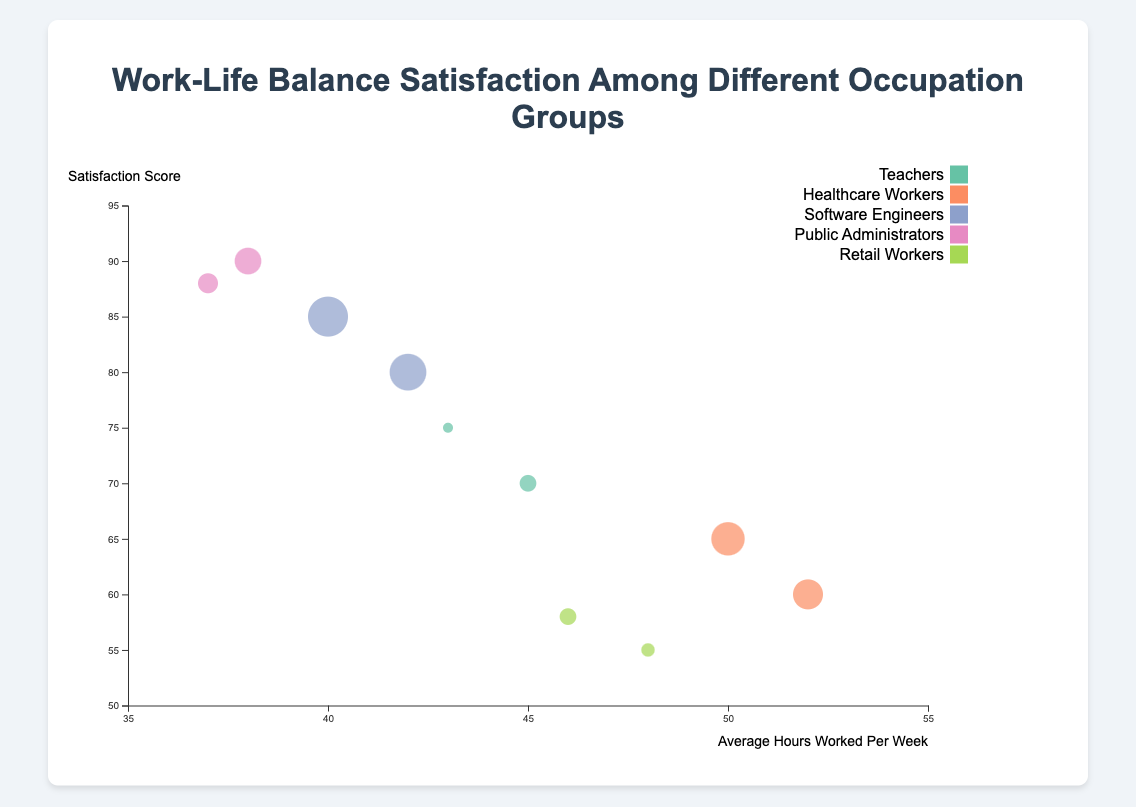What is the title of the chart? The title is usually displayed at the top of the chart. It is written in a larger font size compared to other texts.
Answer: Work-Life Balance Satisfaction Among Different Occupation Groups Which occupation group works the least average hours per week? Look for the data point with the smallest value on the x-axis (Average Hours Worked Per Week).
Answer: Public Administrators (Boston) Which occupation group has the highest satisfaction score? Find the data point with the highest value on the y-axis (Satisfaction Score).
Answer: Public Administrators (Washington D.C.) How many data points are shown on the chart? Count all the individual circles representing each occupation group in the chart.
Answer: 10 Which city has the highest number of respondents for Software Engineers? Compare the sizes of the bubbles representing Software Engineers. The largest bubble will indicate the highest number of respondents.
Answer: San Francisco Compare the satisfaction scores between Healthcare Workers in Chicago and Houston. Which city has a higher score? Locate the two data points for Healthcare Workers. Compare their y-axis values.
Answer: Chicago What is the average satisfaction score of Teachers in New York and Los Angeles combined? Average the satisfaction scores for Teachers in both cities: (70 + 75) / 2 = 72.5
Answer: 72.5 How many more respondents are there for Healthcare Workers in Chicago compared to Houston? Subtract the number of respondents in Houston from the number in Chicago: 200 - 190 = 10
Answer: 10 Which occupation group has the highest work-life balance satisfaction combined for all their data points? Identify the occupation group with the highest combined satisfaction scores from all their data points: Software Engineers (85 + 80) / 2 = 82.5
Answer: Software Engineers Find the occupation group with the smallest bubble size. Look at the circle with the smallest radius, indicating the fewest number of respondents.
Answer: Teachers (Los Angeles) 